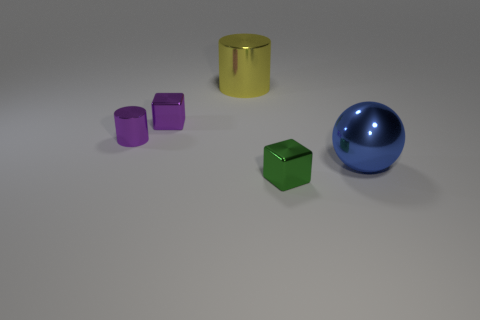Subtract all purple blocks. How many blocks are left? 1 Add 1 big cylinders. How many objects exist? 6 Subtract all balls. How many objects are left? 4 Subtract 1 cubes. How many cubes are left? 1 Add 3 small purple metallic cylinders. How many small purple metallic cylinders exist? 4 Subtract 0 blue cubes. How many objects are left? 5 Subtract all purple cubes. Subtract all red cylinders. How many cubes are left? 1 Subtract all cyan cylinders. Subtract all purple cylinders. How many objects are left? 4 Add 1 big blue metal spheres. How many big blue metal spheres are left? 2 